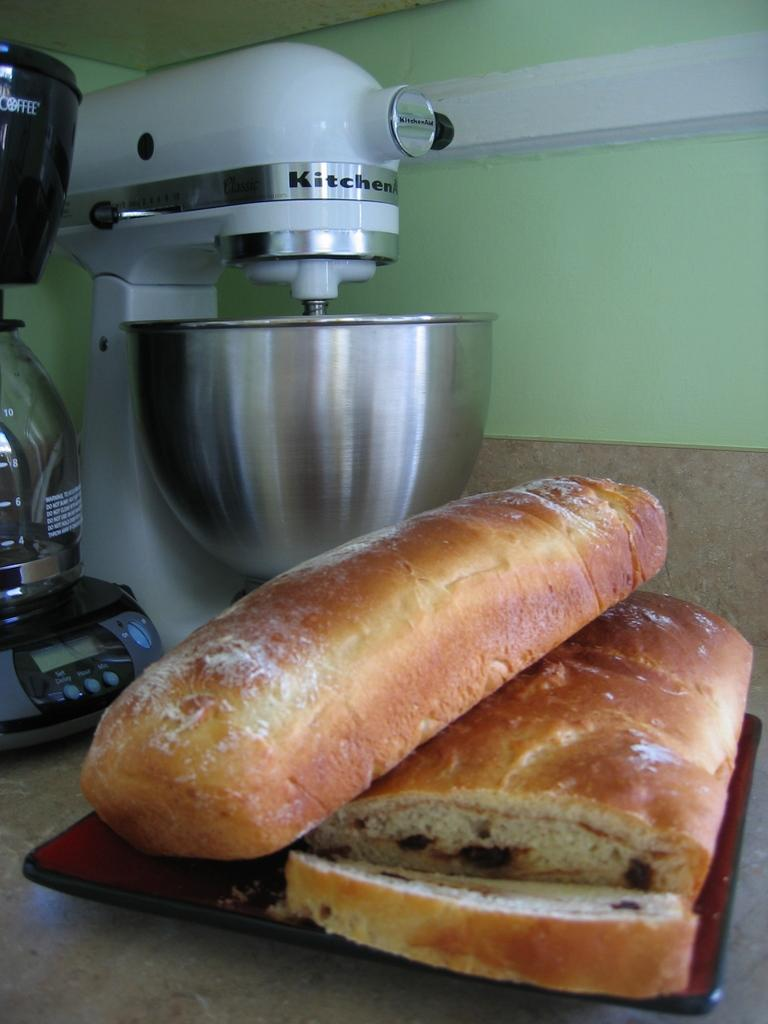<image>
Write a terse but informative summary of the picture. Loaves of bread next to a blender that says Kitchen 